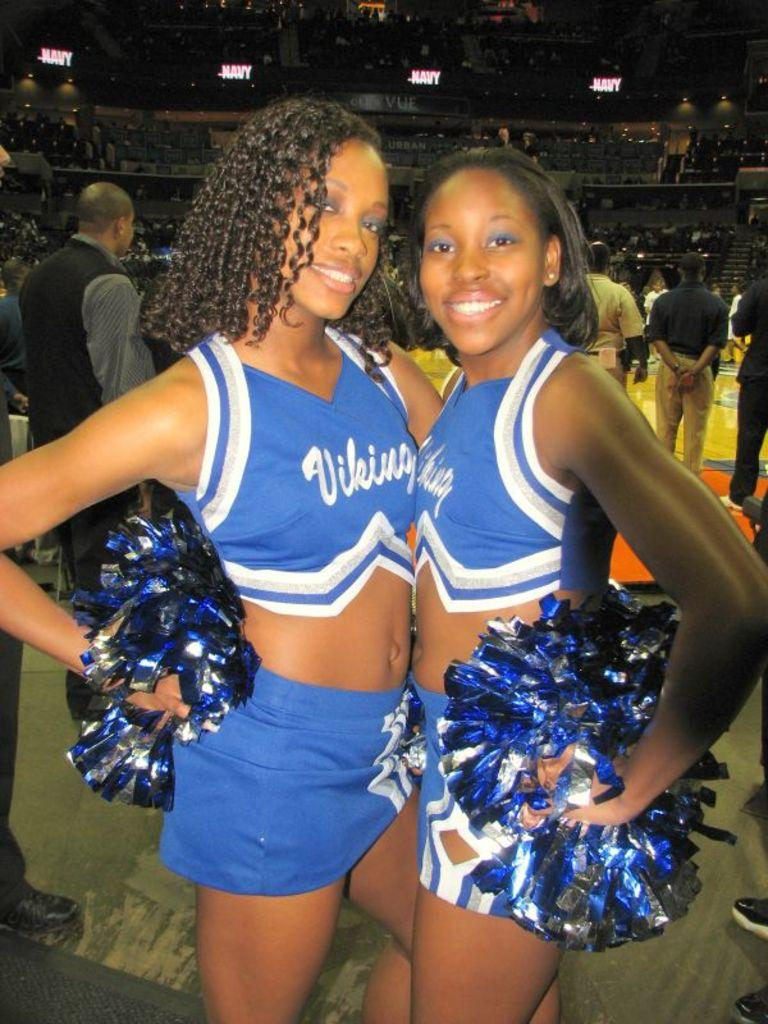<image>
Summarize the visual content of the image. The cheerleaders have uniforms on that says Vikings on the front 